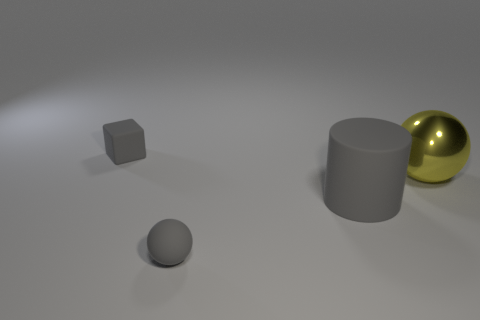Add 3 large blue metallic cylinders. How many objects exist? 7 Subtract all gray balls. How many balls are left? 1 Subtract all cylinders. How many objects are left? 3 Subtract 1 balls. How many balls are left? 1 Subtract all red cylinders. Subtract all gray cubes. How many cylinders are left? 1 Subtract all large things. Subtract all yellow things. How many objects are left? 1 Add 3 small blocks. How many small blocks are left? 4 Add 2 small blue metallic cubes. How many small blue metallic cubes exist? 2 Subtract 0 red cylinders. How many objects are left? 4 